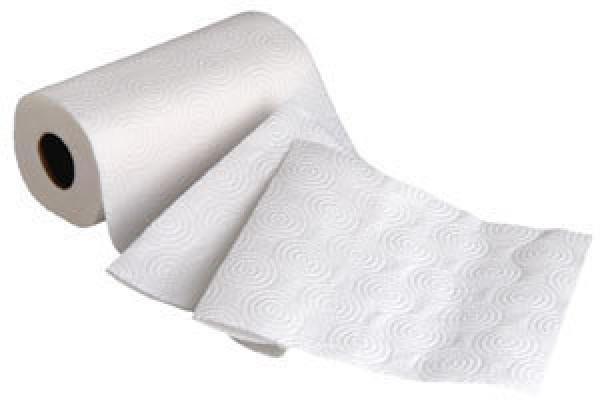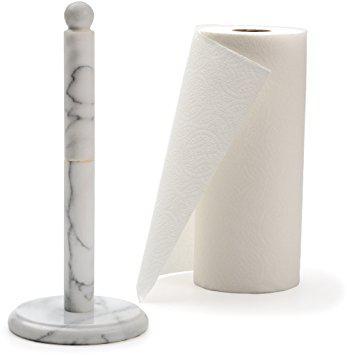The first image is the image on the left, the second image is the image on the right. Considering the images on both sides, is "Only one roll is shown on a stand holder." valid? Answer yes or no. No. 